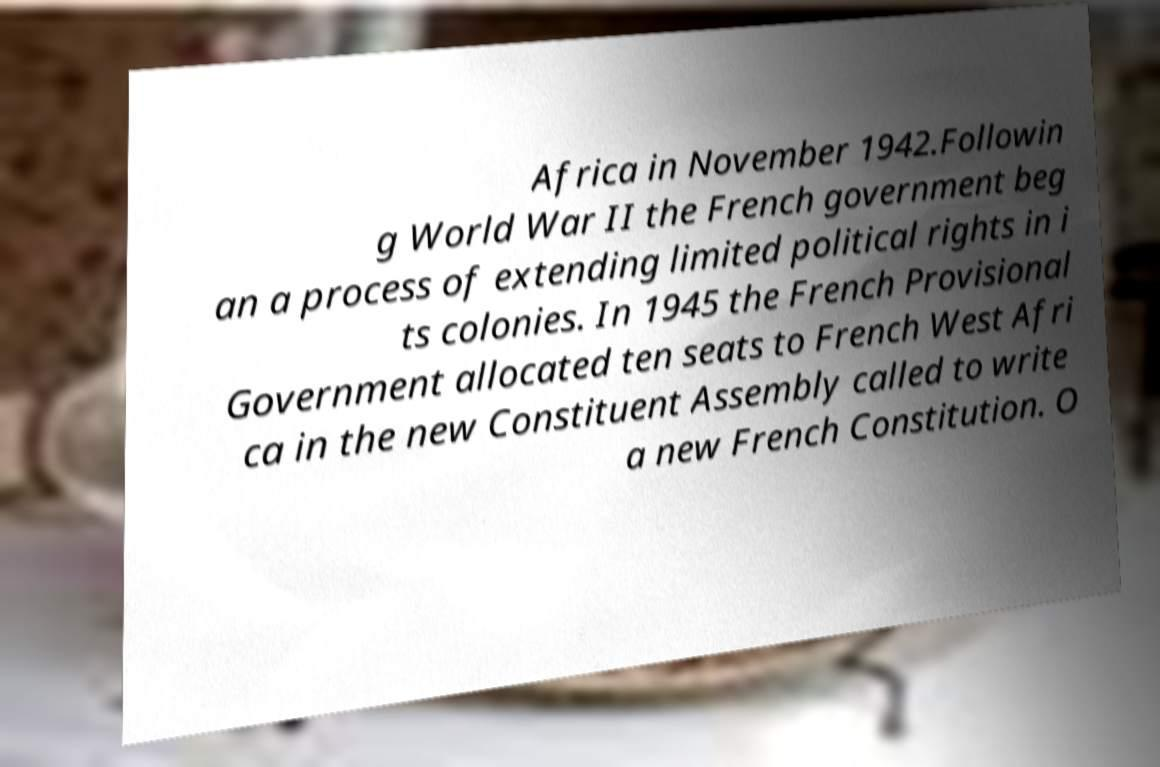Could you assist in decoding the text presented in this image and type it out clearly? Africa in November 1942.Followin g World War II the French government beg an a process of extending limited political rights in i ts colonies. In 1945 the French Provisional Government allocated ten seats to French West Afri ca in the new Constituent Assembly called to write a new French Constitution. O 